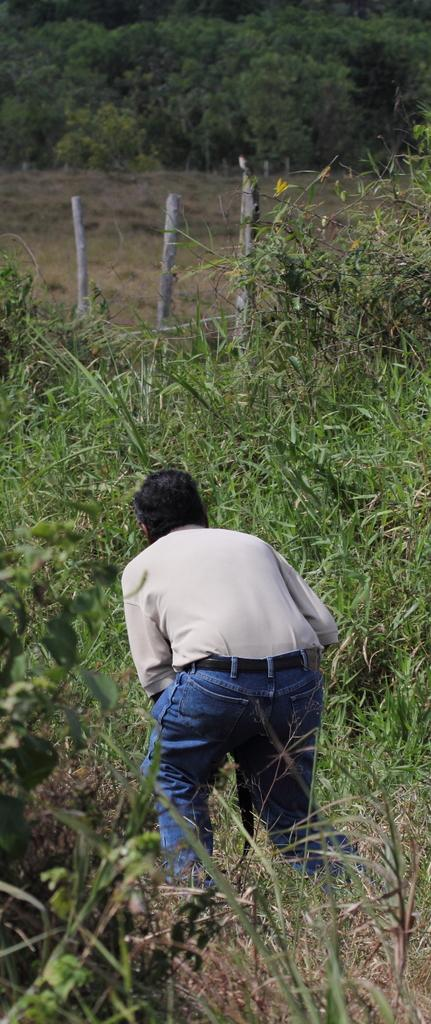What is the dominant feature of the landscape in the image? There is a lot of grass in the image. Can you describe the person's location in the image? There is a person in between the grass. What can be seen in the background of the image? There are many trees in the background of the image. What type of insurance does the person in the image have for their dinosaurs? There are no dinosaurs present in the image, and therefore no insurance is needed for them. 